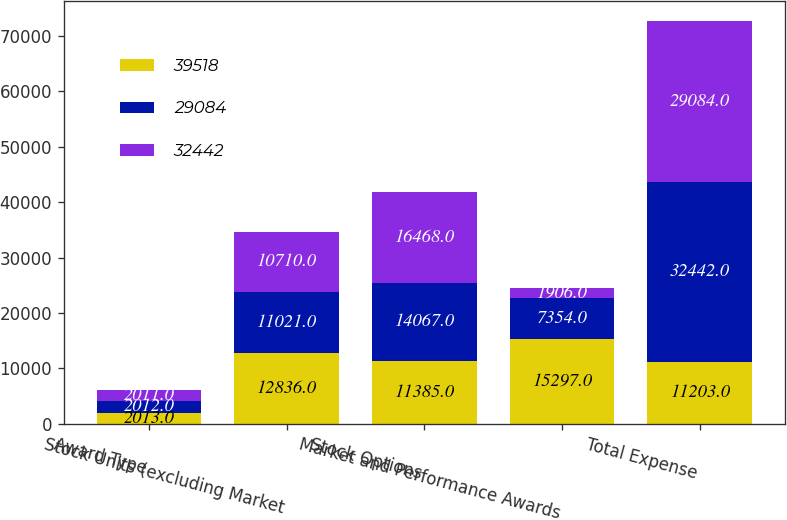Convert chart to OTSL. <chart><loc_0><loc_0><loc_500><loc_500><stacked_bar_chart><ecel><fcel>Award Type<fcel>Stock Units (excluding Market<fcel>Stock Options<fcel>Market and Performance Awards<fcel>Total Expense<nl><fcel>39518<fcel>2013<fcel>12836<fcel>11385<fcel>15297<fcel>11203<nl><fcel>29084<fcel>2012<fcel>11021<fcel>14067<fcel>7354<fcel>32442<nl><fcel>32442<fcel>2011<fcel>10710<fcel>16468<fcel>1906<fcel>29084<nl></chart> 